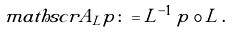Convert formula to latex. <formula><loc_0><loc_0><loc_500><loc_500>\ m a t h s c r { A } _ { L } p \colon = L ^ { - 1 } \, p \circ L \, .</formula> 